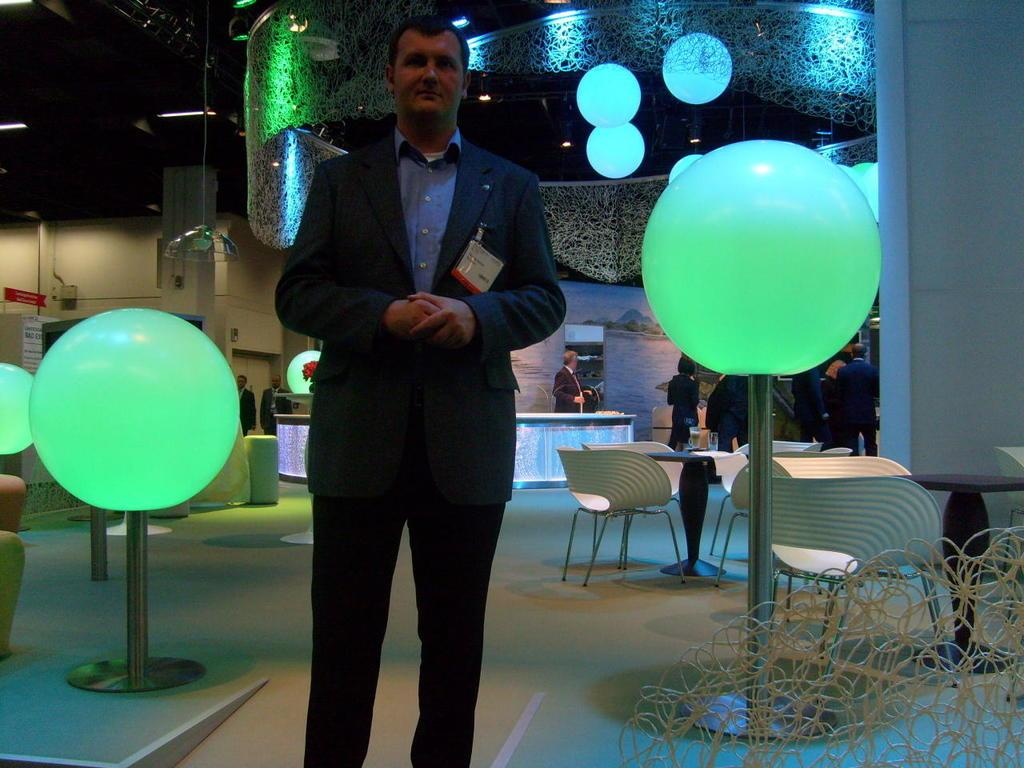What is the person in the image wearing? The person is wearing a suit. What can be seen in the background of the image? There are lights visible in the image. What object with a pole is present in the image? There is a ball with a pole in the image. What type of furniture is present in the image? Chairs and tables are present in the image. How many rabbits can be seen playing with a list in the image? There are no rabbits or lists present in the image. 